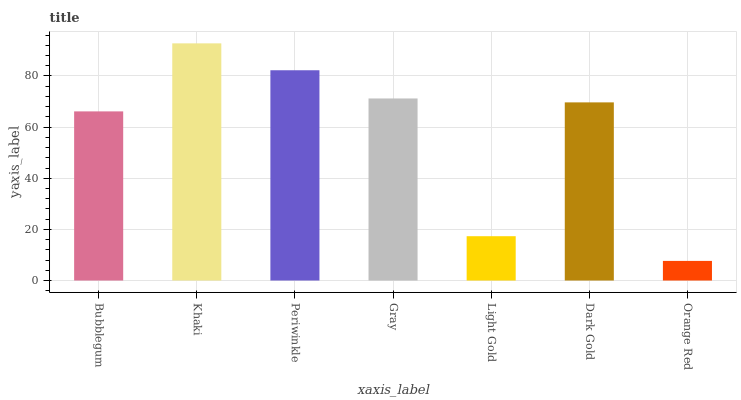Is Orange Red the minimum?
Answer yes or no. Yes. Is Khaki the maximum?
Answer yes or no. Yes. Is Periwinkle the minimum?
Answer yes or no. No. Is Periwinkle the maximum?
Answer yes or no. No. Is Khaki greater than Periwinkle?
Answer yes or no. Yes. Is Periwinkle less than Khaki?
Answer yes or no. Yes. Is Periwinkle greater than Khaki?
Answer yes or no. No. Is Khaki less than Periwinkle?
Answer yes or no. No. Is Dark Gold the high median?
Answer yes or no. Yes. Is Dark Gold the low median?
Answer yes or no. Yes. Is Orange Red the high median?
Answer yes or no. No. Is Gray the low median?
Answer yes or no. No. 